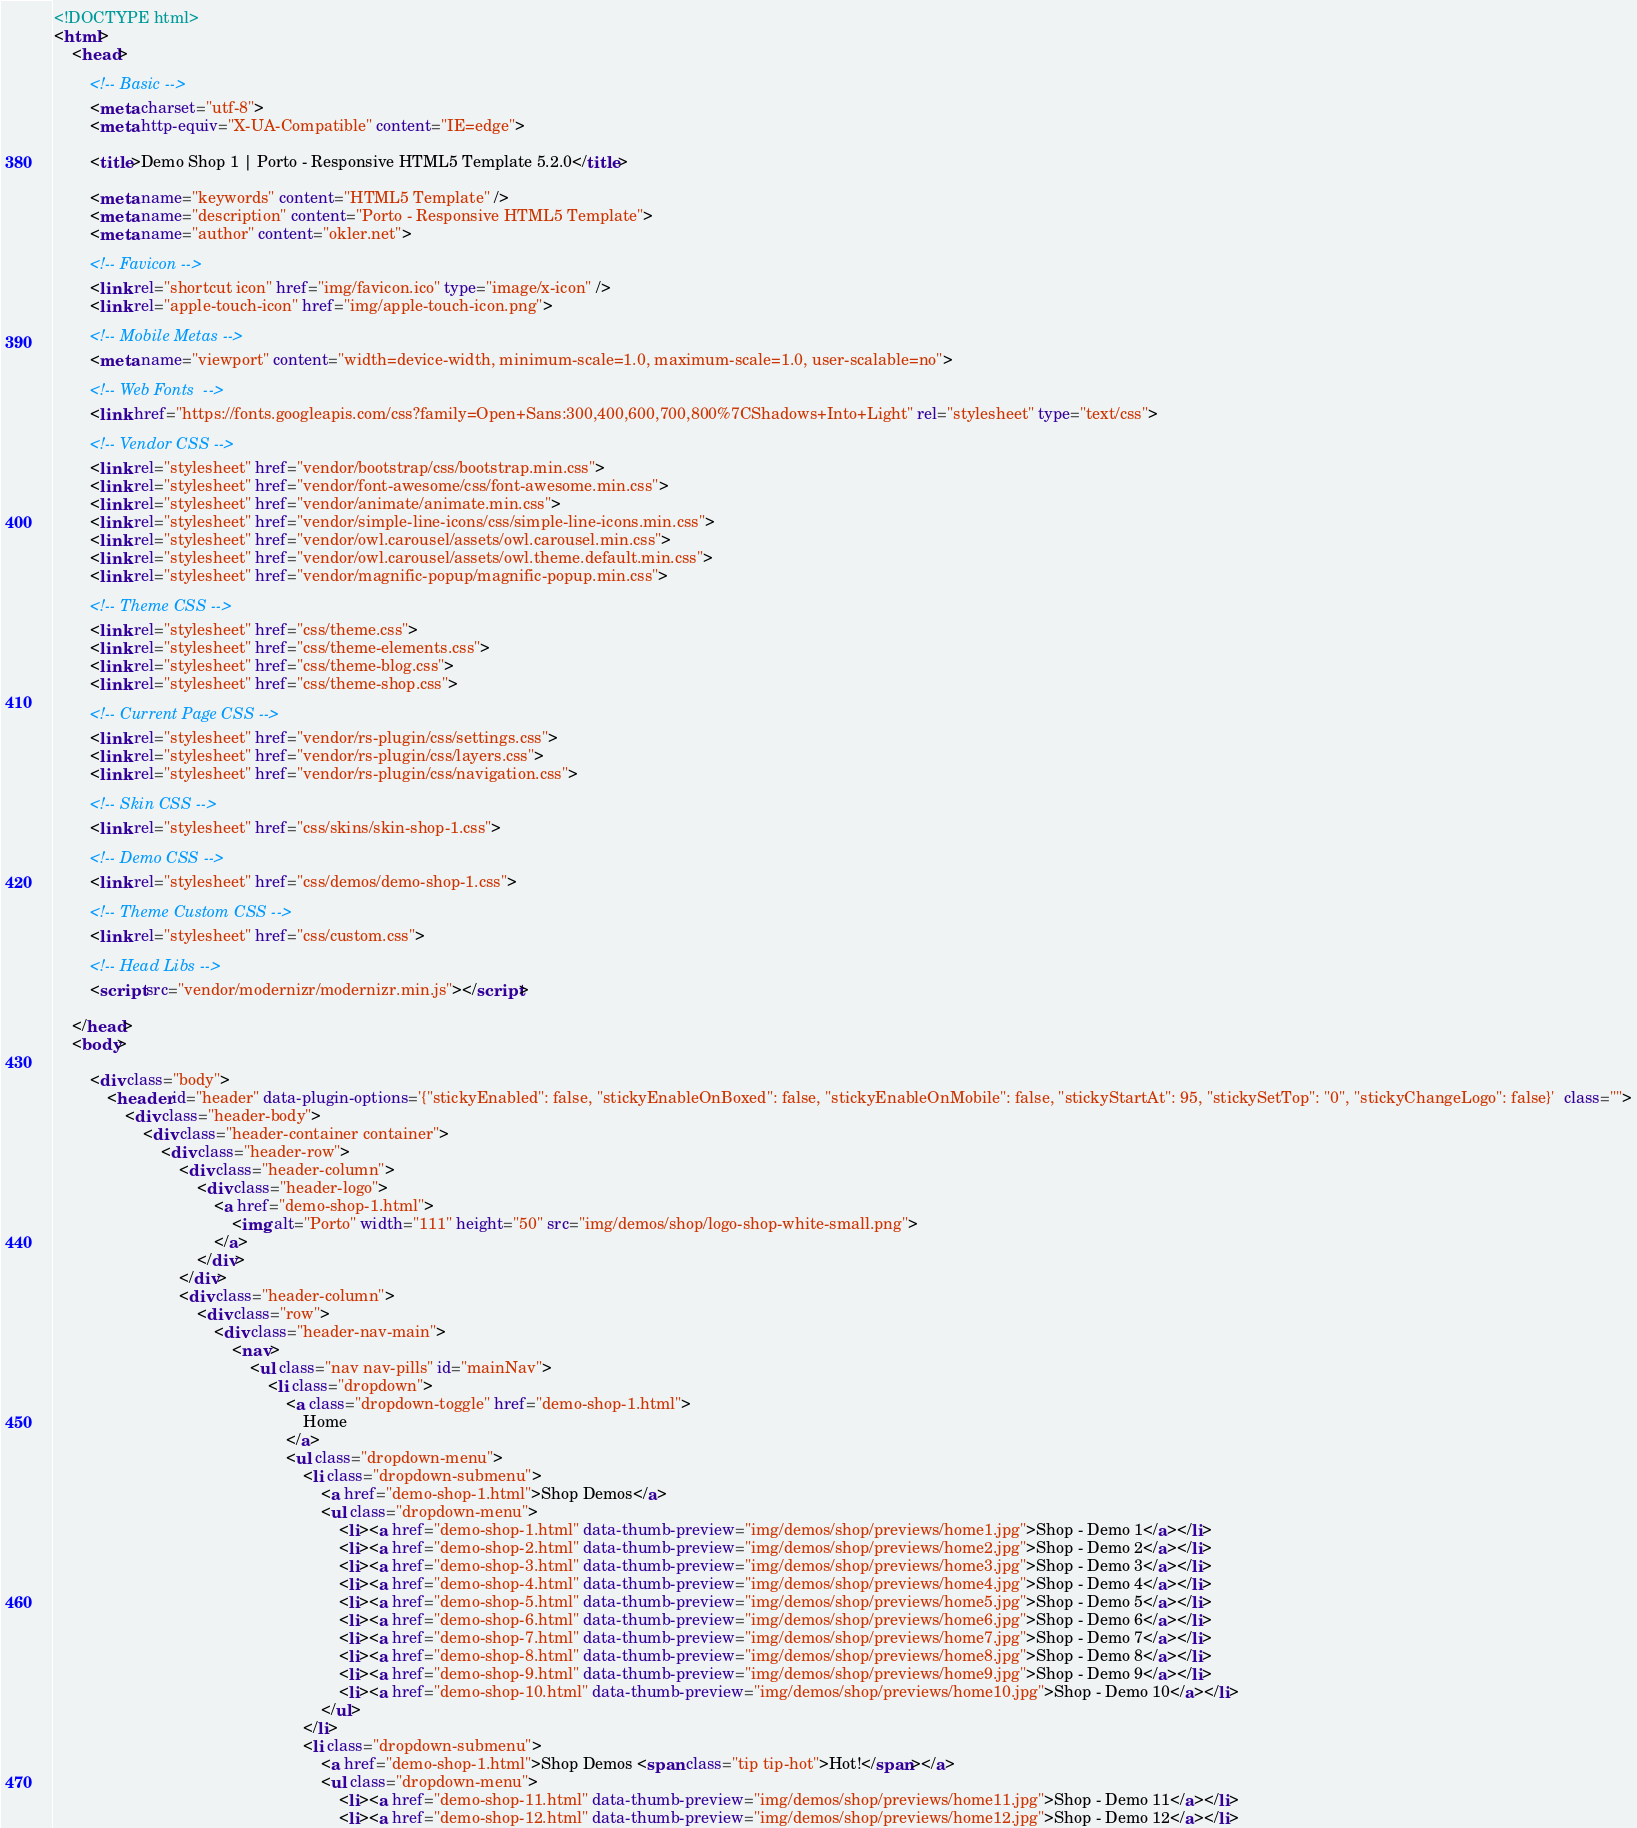Convert code to text. <code><loc_0><loc_0><loc_500><loc_500><_HTML_><!DOCTYPE html>
<html>
	<head>

		<!-- Basic -->
		<meta charset="utf-8">
		<meta http-equiv="X-UA-Compatible" content="IE=edge">	

		<title>Demo Shop 1 | Porto - Responsive HTML5 Template 5.2.0</title>	

		<meta name="keywords" content="HTML5 Template" />
		<meta name="description" content="Porto - Responsive HTML5 Template">
		<meta name="author" content="okler.net">

		<!-- Favicon -->
		<link rel="shortcut icon" href="img/favicon.ico" type="image/x-icon" />
		<link rel="apple-touch-icon" href="img/apple-touch-icon.png">

		<!-- Mobile Metas -->
		<meta name="viewport" content="width=device-width, minimum-scale=1.0, maximum-scale=1.0, user-scalable=no">

		<!-- Web Fonts  -->
		<link href="https://fonts.googleapis.com/css?family=Open+Sans:300,400,600,700,800%7CShadows+Into+Light" rel="stylesheet" type="text/css">

		<!-- Vendor CSS -->
		<link rel="stylesheet" href="vendor/bootstrap/css/bootstrap.min.css">
		<link rel="stylesheet" href="vendor/font-awesome/css/font-awesome.min.css">
		<link rel="stylesheet" href="vendor/animate/animate.min.css">
		<link rel="stylesheet" href="vendor/simple-line-icons/css/simple-line-icons.min.css">
		<link rel="stylesheet" href="vendor/owl.carousel/assets/owl.carousel.min.css">
		<link rel="stylesheet" href="vendor/owl.carousel/assets/owl.theme.default.min.css">
		<link rel="stylesheet" href="vendor/magnific-popup/magnific-popup.min.css">

		<!-- Theme CSS -->
		<link rel="stylesheet" href="css/theme.css">
		<link rel="stylesheet" href="css/theme-elements.css">
		<link rel="stylesheet" href="css/theme-blog.css">
		<link rel="stylesheet" href="css/theme-shop.css">

		<!-- Current Page CSS -->
		<link rel="stylesheet" href="vendor/rs-plugin/css/settings.css">
		<link rel="stylesheet" href="vendor/rs-plugin/css/layers.css">
		<link rel="stylesheet" href="vendor/rs-plugin/css/navigation.css">

		<!-- Skin CSS -->
		<link rel="stylesheet" href="css/skins/skin-shop-1.css"> 

		<!-- Demo CSS -->		<link rel="stylesheet" href="css/demos/demo-shop-1.css">

		<!-- Theme Custom CSS -->
		<link rel="stylesheet" href="css/custom.css">

		<!-- Head Libs -->
		<script src="vendor/modernizr/modernizr.min.js"></script>

	</head>
	<body>

		<div class="body">
			<header id="header" data-plugin-options='{"stickyEnabled": false, "stickyEnableOnBoxed": false, "stickyEnableOnMobile": false, "stickyStartAt": 95, "stickySetTop": "0", "stickyChangeLogo": false}'  class="">
				<div class="header-body">
					<div class="header-container container">
						<div class="header-row">
							<div class="header-column">
								<div class="header-logo">
									<a href="demo-shop-1.html">
										<img alt="Porto" width="111" height="50" src="img/demos/shop/logo-shop-white-small.png">
									</a>
								</div>
							</div>
							<div class="header-column">
								<div class="row">
									<div class="header-nav-main">
										<nav>
											<ul class="nav nav-pills" id="mainNav">
												<li class="dropdown">
													<a class="dropdown-toggle" href="demo-shop-1.html">
														Home
													</a>
													<ul class="dropdown-menu">
														<li class="dropdown-submenu">
															<a href="demo-shop-1.html">Shop Demos</a>
															<ul class="dropdown-menu">
																<li><a href="demo-shop-1.html" data-thumb-preview="img/demos/shop/previews/home1.jpg">Shop - Demo 1</a></li>
																<li><a href="demo-shop-2.html" data-thumb-preview="img/demos/shop/previews/home2.jpg">Shop - Demo 2</a></li>
																<li><a href="demo-shop-3.html" data-thumb-preview="img/demos/shop/previews/home3.jpg">Shop - Demo 3</a></li>
																<li><a href="demo-shop-4.html" data-thumb-preview="img/demos/shop/previews/home4.jpg">Shop - Demo 4</a></li>
																<li><a href="demo-shop-5.html" data-thumb-preview="img/demos/shop/previews/home5.jpg">Shop - Demo 5</a></li>
																<li><a href="demo-shop-6.html" data-thumb-preview="img/demos/shop/previews/home6.jpg">Shop - Demo 6</a></li>
																<li><a href="demo-shop-7.html" data-thumb-preview="img/demos/shop/previews/home7.jpg">Shop - Demo 7</a></li>
																<li><a href="demo-shop-8.html" data-thumb-preview="img/demos/shop/previews/home8.jpg">Shop - Demo 8</a></li>
																<li><a href="demo-shop-9.html" data-thumb-preview="img/demos/shop/previews/home9.jpg">Shop - Demo 9</a></li>
																<li><a href="demo-shop-10.html" data-thumb-preview="img/demos/shop/previews/home10.jpg">Shop - Demo 10</a></li>
															</ul>
														</li>
														<li class="dropdown-submenu">
															<a href="demo-shop-1.html">Shop Demos <span class="tip tip-hot">Hot!</span></a>
															<ul class="dropdown-menu">
																<li><a href="demo-shop-11.html" data-thumb-preview="img/demos/shop/previews/home11.jpg">Shop - Demo 11</a></li>
																<li><a href="demo-shop-12.html" data-thumb-preview="img/demos/shop/previews/home12.jpg">Shop - Demo 12</a></li></code> 